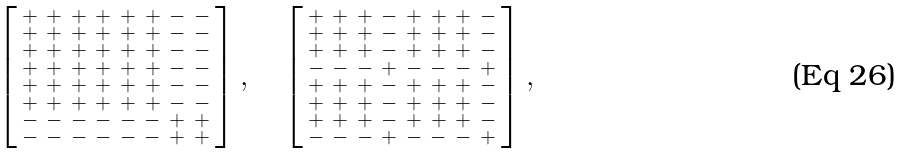Convert formula to latex. <formula><loc_0><loc_0><loc_500><loc_500>\left [ \begin{smallmatrix} + & + & + & + & + & + & - & - \\ + & + & + & + & + & + & - & - \\ + & + & + & + & + & + & - & - \\ + & + & + & + & + & + & - & - \\ + & + & + & + & + & + & - & - \\ + & + & + & + & + & + & - & - \\ - & - & - & - & - & - & + & + \\ - & - & - & - & - & - & + & + \end{smallmatrix} \right ] , \quad \left [ \begin{smallmatrix} + & + & + & - & + & + & + & - \\ + & + & + & - & + & + & + & - \\ + & + & + & - & + & + & + & - \\ - & - & - & + & - & - & - & + \\ + & + & + & - & + & + & + & - \\ + & + & + & - & + & + & + & - \\ + & + & + & - & + & + & + & - \\ - & - & - & + & - & - & - & + \end{smallmatrix} \right ] ,</formula> 